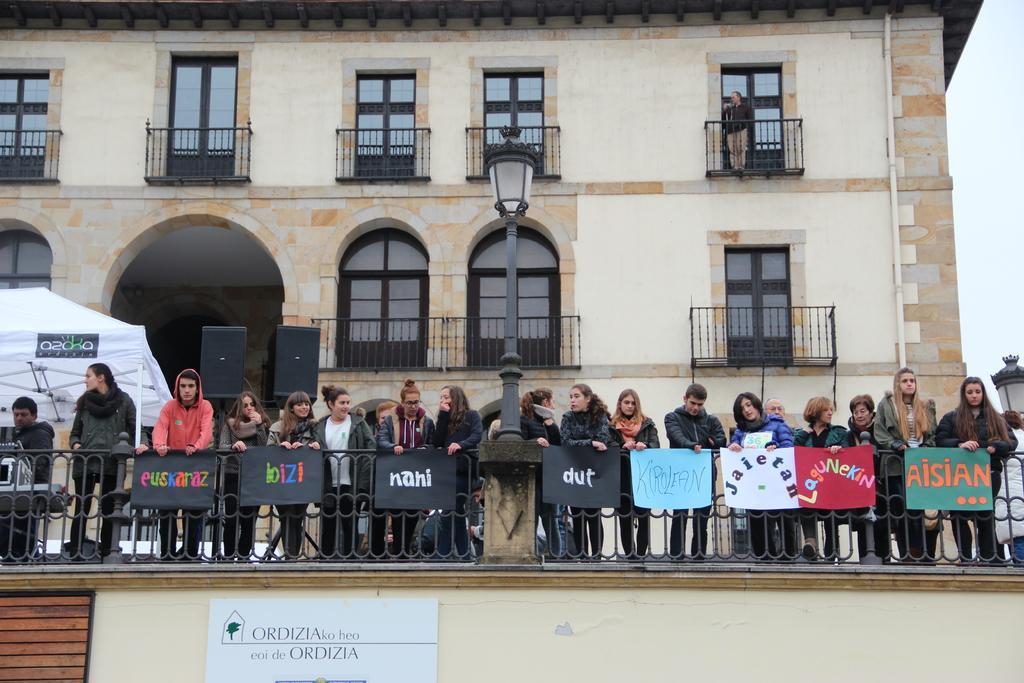Describe this image in one or two sentences. In the foreground of the picture there are people standing near the railing, to the railing there are banners. On the left there is a tent. In the background there is a building and windows. In the center of the picture there is a street light. Sky is cloudy. 